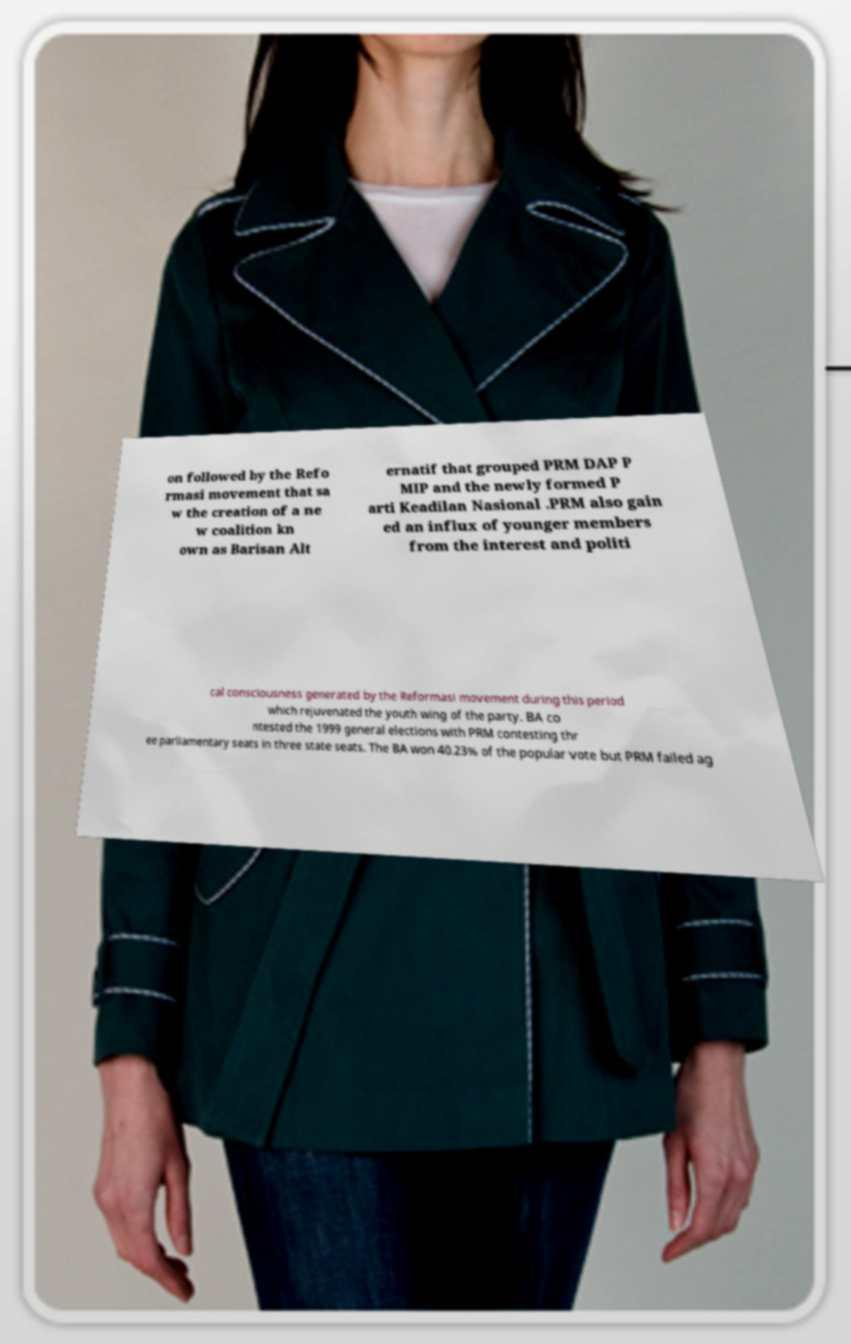What messages or text are displayed in this image? I need them in a readable, typed format. on followed by the Refo rmasi movement that sa w the creation of a ne w coalition kn own as Barisan Alt ernatif that grouped PRM DAP P MIP and the newly formed P arti Keadilan Nasional .PRM also gain ed an influx of younger members from the interest and politi cal consciousness generated by the Reformasi movement during this period which rejuvenated the youth wing of the party. BA co ntested the 1999 general elections with PRM contesting thr ee parliamentary seats in three state seats. The BA won 40.23% of the popular vote but PRM failed ag 